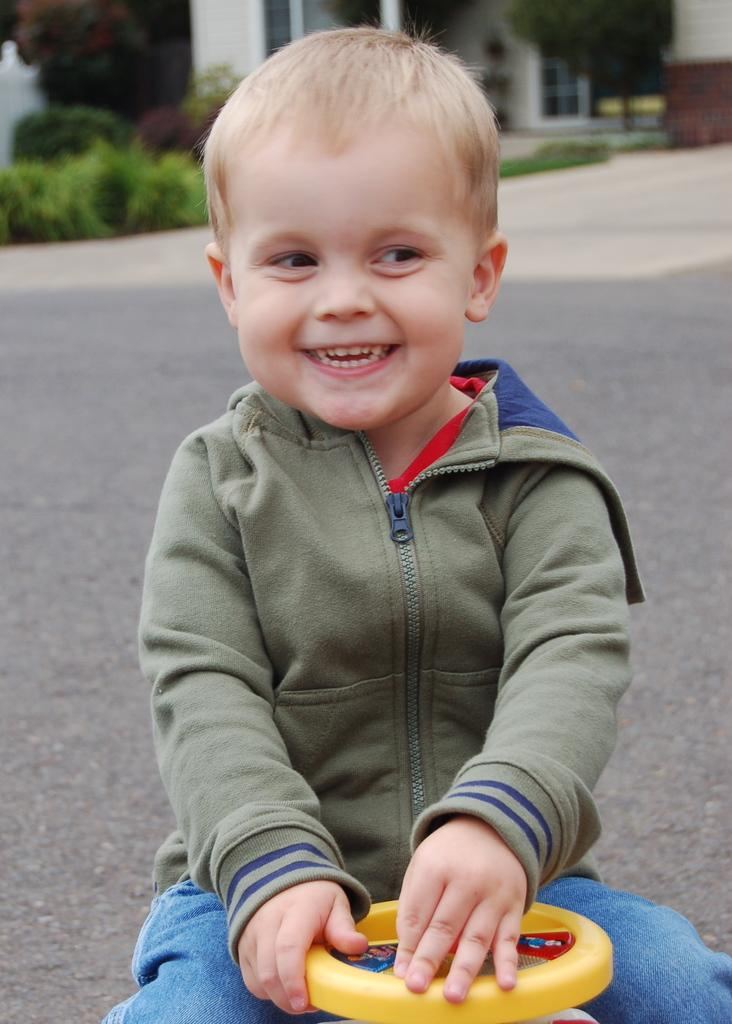Who is present in the image? There is a boy in the image. What is the boy doing in the image? The boy is smiling in the image. What is the boy sitting on in the image? The boy is sitting on a magic car in the image. What can be seen in the background of the image? There is a road, a house, plants, and trees in the background of the image. What type of pot is the boy holding in the image? There is no pot present in the image; the boy is sitting on a magic car. What kind of loaf is the boy eating in the image? There is no loaf present in the image; the boy is smiling and sitting on a magic car. 